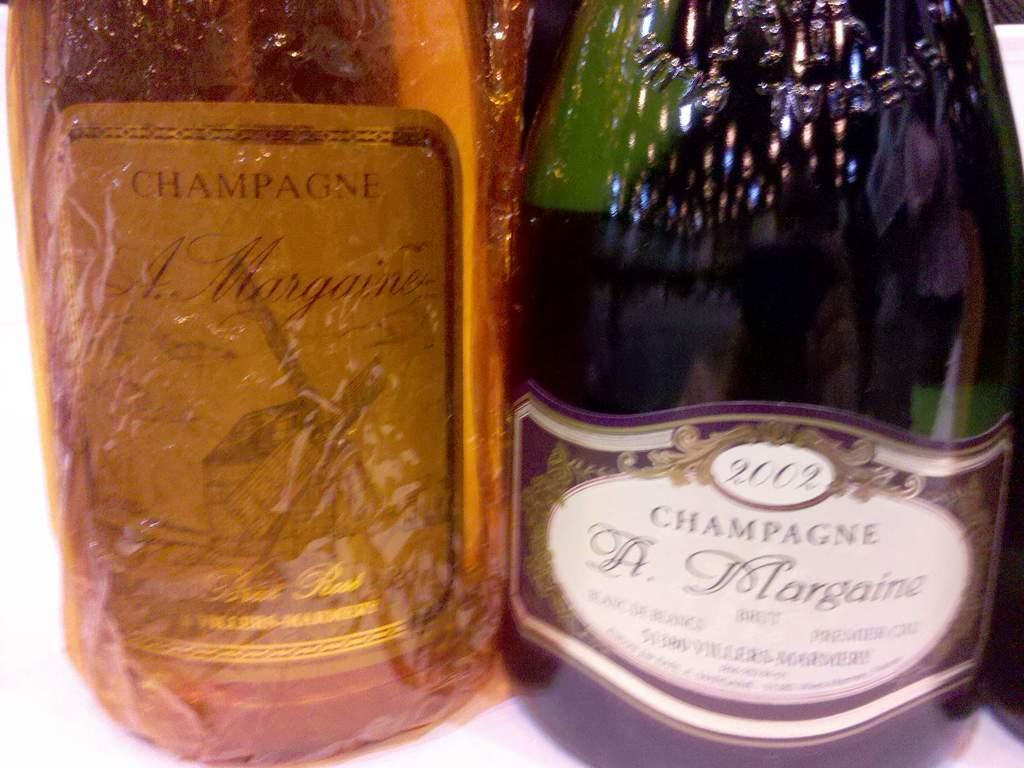<image>
Describe the image concisely. Two bottles of champagne, one of which is dated 2002. 